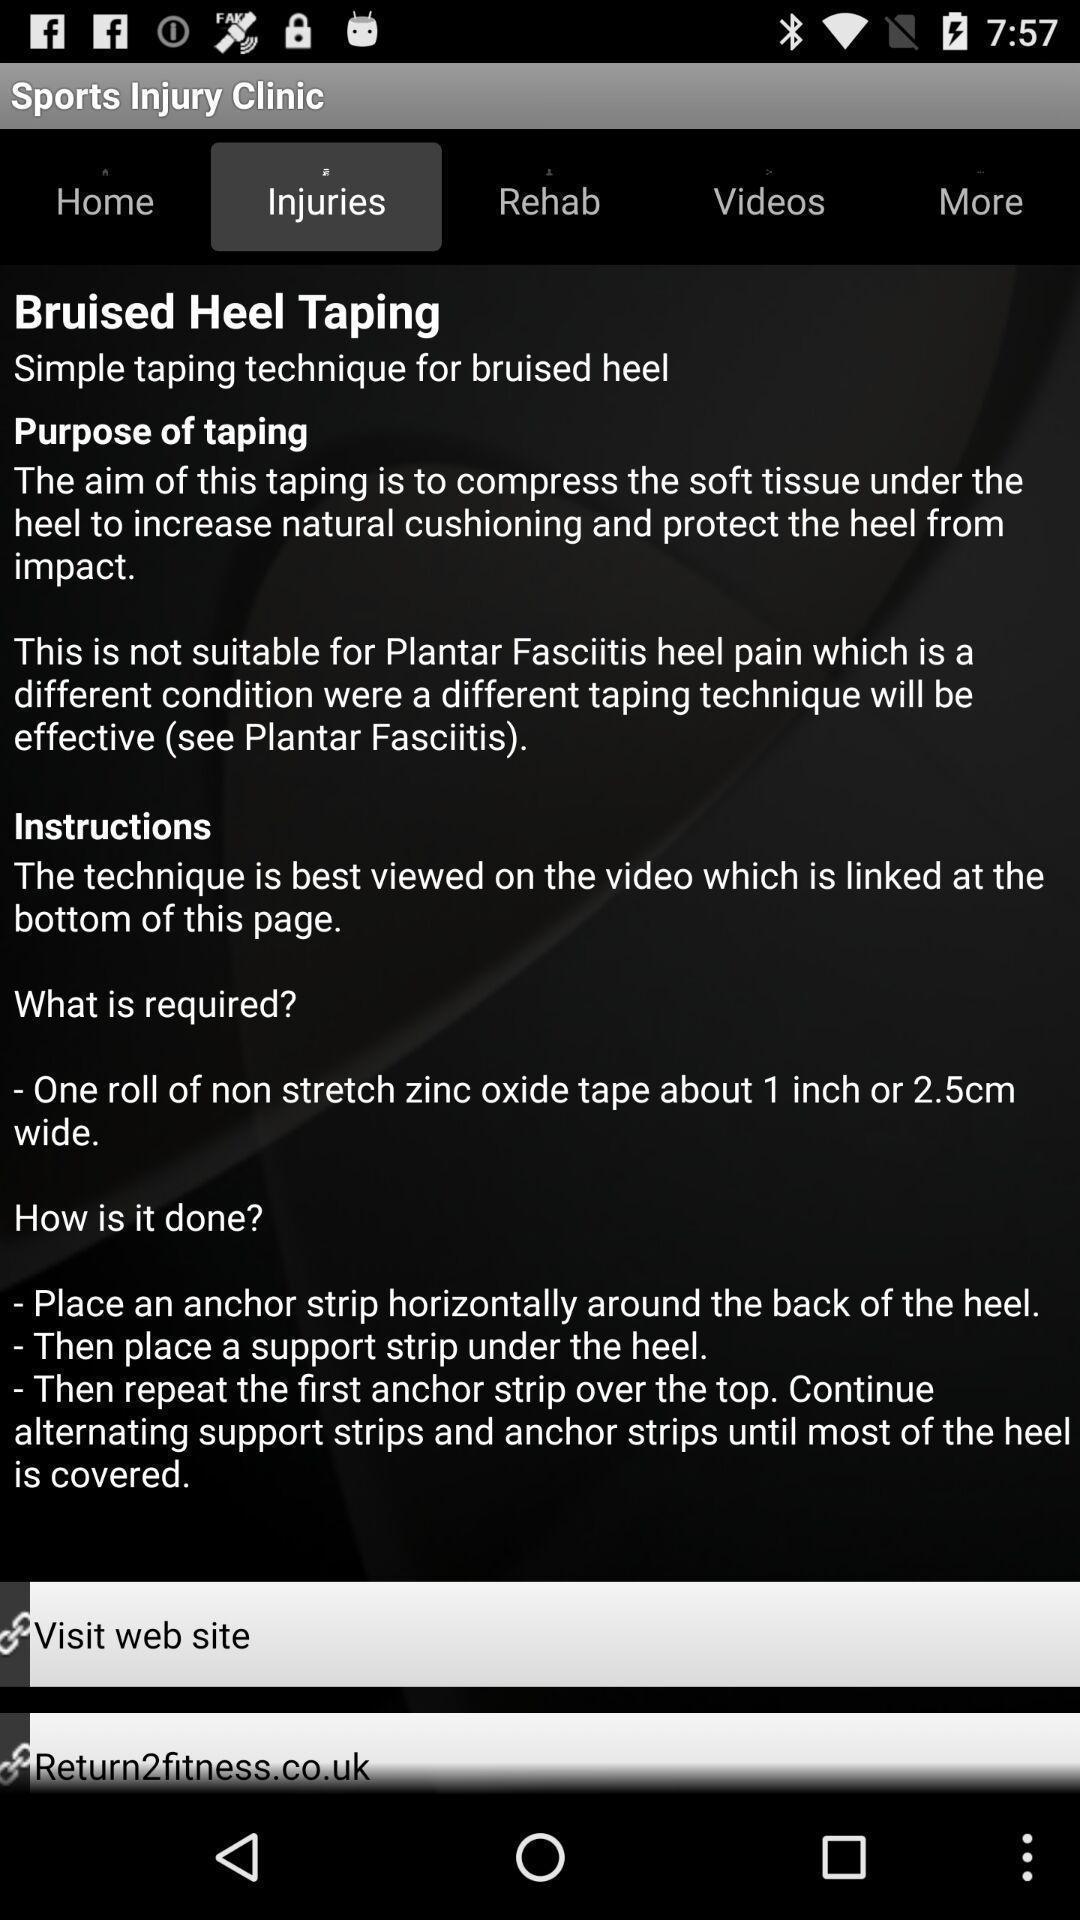Tell me about the visual elements in this screen capture. Page showing information and instructions in medical app. 